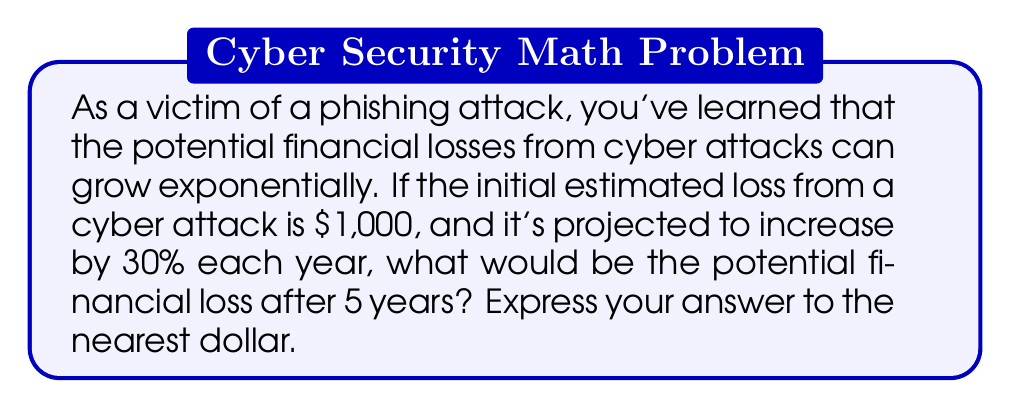Provide a solution to this math problem. To solve this problem, we'll use the exponential growth formula:

$$A = P(1 + r)^t$$

Where:
$A$ = Final amount
$P$ = Principal (initial amount)
$r$ = Growth rate (as a decimal)
$t$ = Time period

Given:
$P = 1000$ (initial loss of $1,000)
$r = 0.30$ (30% growth rate)
$t = 5$ years

Let's plug these values into the formula:

$$A = 1000(1 + 0.30)^5$$

Now, let's calculate step by step:

1) First, calculate $(1 + 0.30)$:
   $1 + 0.30 = 1.30$

2) Now, raise 1.30 to the power of 5:
   $1.30^5 \approx 3.7130$

3) Finally, multiply this by the initial amount:
   $1000 \times 3.7130 \approx 3713.00$

Therefore, the potential financial loss after 5 years would be approximately $3,713.
Answer: $3,713 